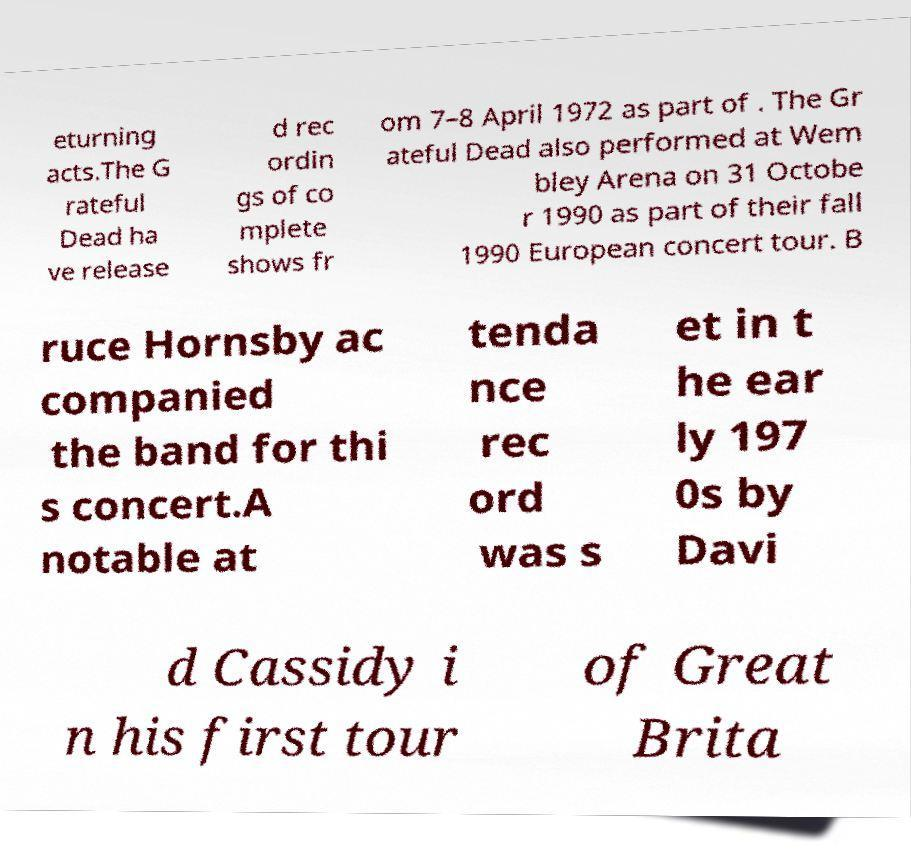Could you assist in decoding the text presented in this image and type it out clearly? eturning acts.The G rateful Dead ha ve release d rec ordin gs of co mplete shows fr om 7–8 April 1972 as part of . The Gr ateful Dead also performed at Wem bley Arena on 31 Octobe r 1990 as part of their fall 1990 European concert tour. B ruce Hornsby ac companied the band for thi s concert.A notable at tenda nce rec ord was s et in t he ear ly 197 0s by Davi d Cassidy i n his first tour of Great Brita 